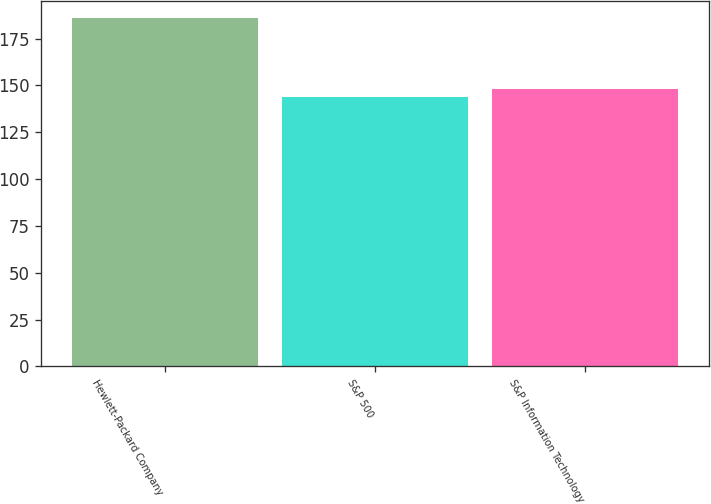<chart> <loc_0><loc_0><loc_500><loc_500><bar_chart><fcel>Hewlett-Packard Company<fcel>S&P 500<fcel>S&P Information Technology<nl><fcel>185.85<fcel>143.71<fcel>147.92<nl></chart> 